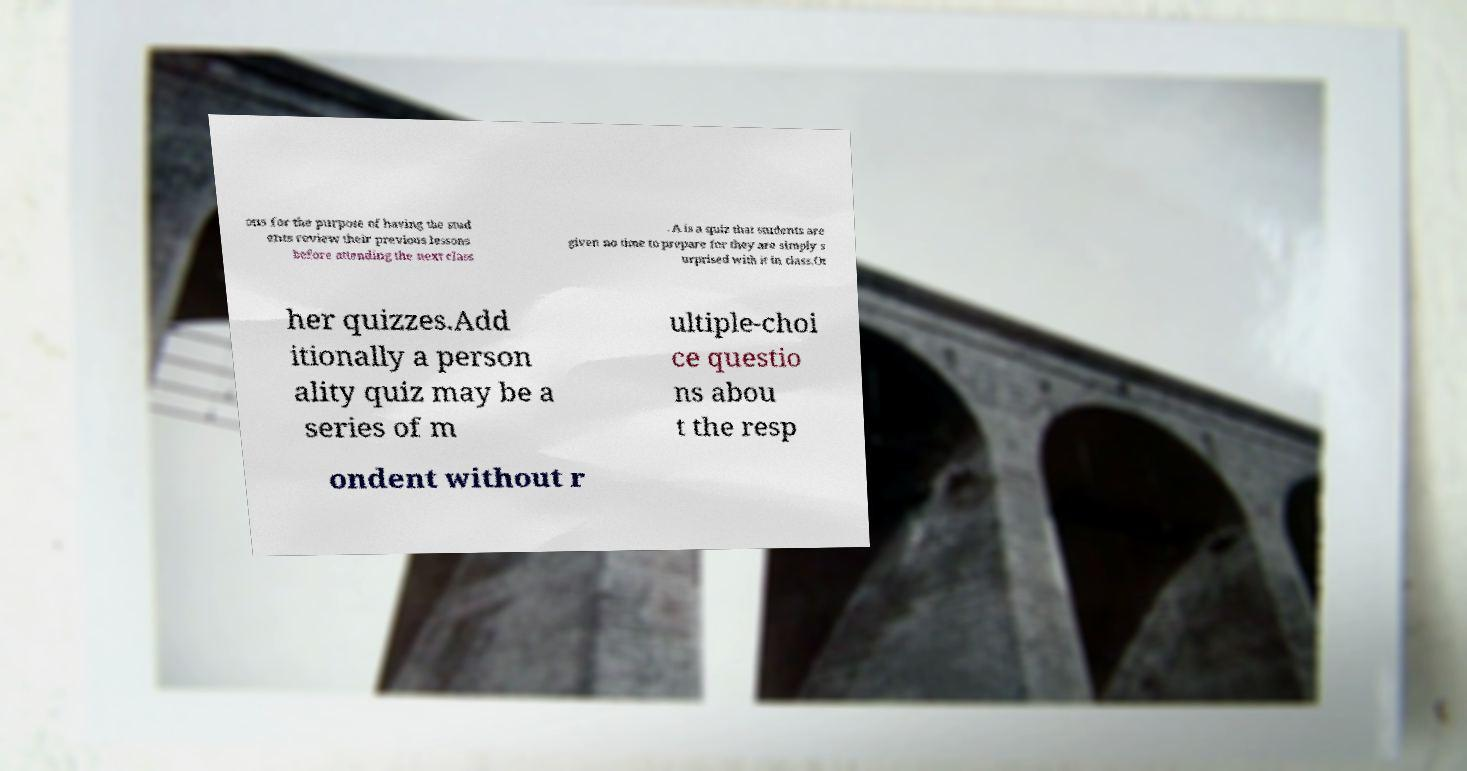Please read and relay the text visible in this image. What does it say? ons for the purpose of having the stud ents review their previous lessons before attending the next class . A is a quiz that students are given no time to prepare for they are simply s urprised with it in class.Ot her quizzes.Add itionally a person ality quiz may be a series of m ultiple-choi ce questio ns abou t the resp ondent without r 